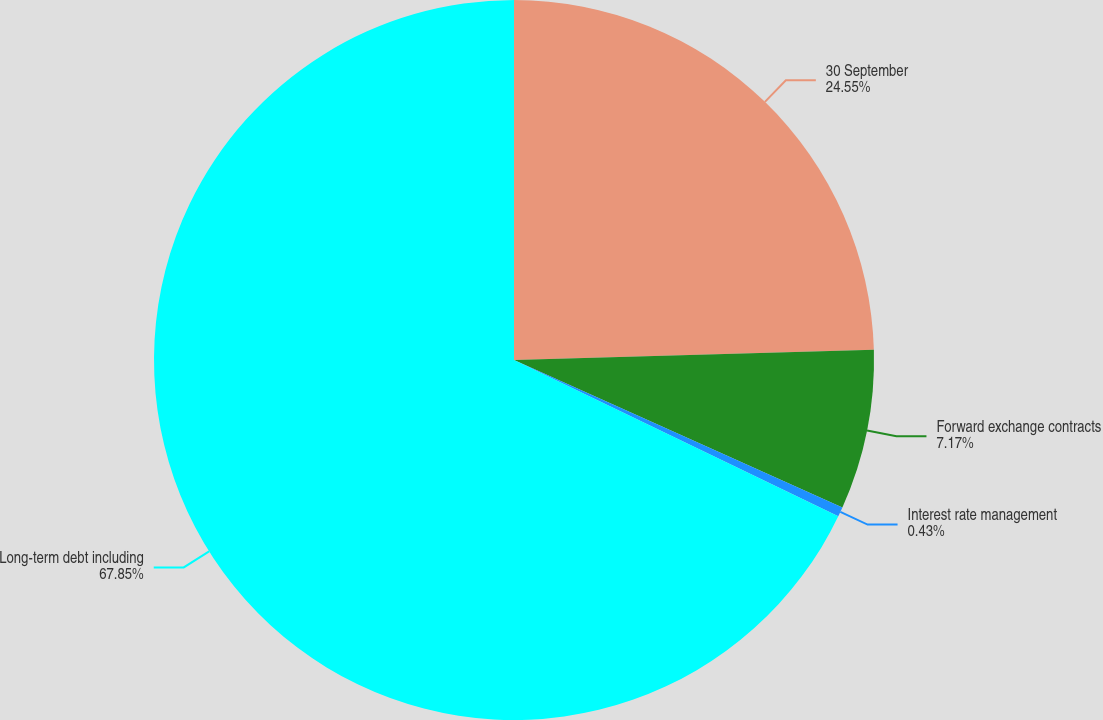Convert chart to OTSL. <chart><loc_0><loc_0><loc_500><loc_500><pie_chart><fcel>30 September<fcel>Forward exchange contracts<fcel>Interest rate management<fcel>Long-term debt including<nl><fcel>24.55%<fcel>7.17%<fcel>0.43%<fcel>67.85%<nl></chart> 